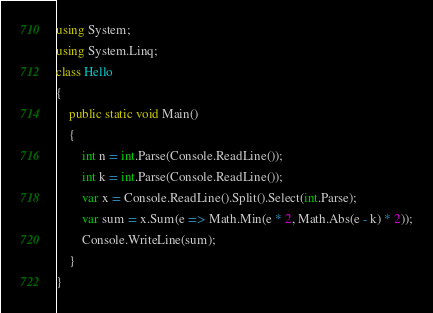Convert code to text. <code><loc_0><loc_0><loc_500><loc_500><_C#_>using System;
using System.Linq;
class Hello
{
    public static void Main()
    {
        int n = int.Parse(Console.ReadLine());
        int k = int.Parse(Console.ReadLine());
        var x = Console.ReadLine().Split().Select(int.Parse);
        var sum = x.Sum(e => Math.Min(e * 2, Math.Abs(e - k) * 2));
        Console.WriteLine(sum);
    }
}
</code> 